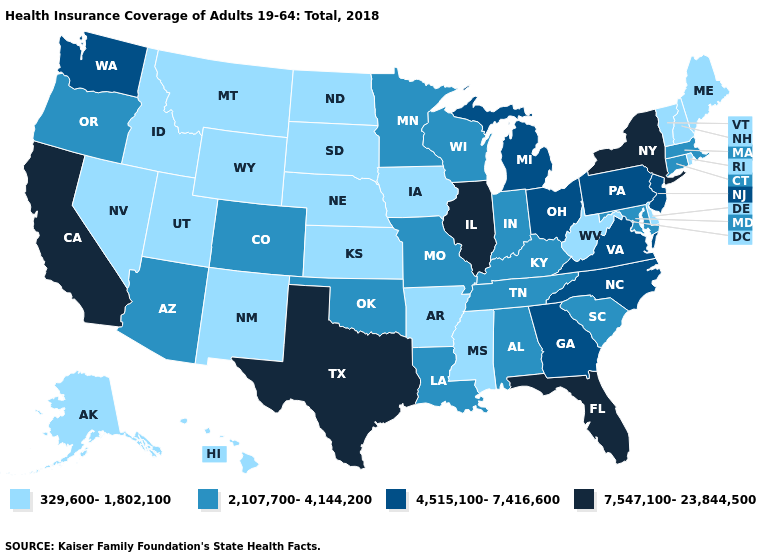Name the states that have a value in the range 329,600-1,802,100?
Write a very short answer. Alaska, Arkansas, Delaware, Hawaii, Idaho, Iowa, Kansas, Maine, Mississippi, Montana, Nebraska, Nevada, New Hampshire, New Mexico, North Dakota, Rhode Island, South Dakota, Utah, Vermont, West Virginia, Wyoming. Name the states that have a value in the range 2,107,700-4,144,200?
Keep it brief. Alabama, Arizona, Colorado, Connecticut, Indiana, Kentucky, Louisiana, Maryland, Massachusetts, Minnesota, Missouri, Oklahoma, Oregon, South Carolina, Tennessee, Wisconsin. What is the lowest value in the USA?
Be succinct. 329,600-1,802,100. Does the map have missing data?
Write a very short answer. No. Which states hav the highest value in the West?
Quick response, please. California. Which states have the highest value in the USA?
Concise answer only. California, Florida, Illinois, New York, Texas. Does Washington have the lowest value in the West?
Write a very short answer. No. Which states have the lowest value in the West?
Be succinct. Alaska, Hawaii, Idaho, Montana, Nevada, New Mexico, Utah, Wyoming. Name the states that have a value in the range 4,515,100-7,416,600?
Short answer required. Georgia, Michigan, New Jersey, North Carolina, Ohio, Pennsylvania, Virginia, Washington. Name the states that have a value in the range 4,515,100-7,416,600?
Keep it brief. Georgia, Michigan, New Jersey, North Carolina, Ohio, Pennsylvania, Virginia, Washington. What is the highest value in the USA?
Quick response, please. 7,547,100-23,844,500. Name the states that have a value in the range 329,600-1,802,100?
Concise answer only. Alaska, Arkansas, Delaware, Hawaii, Idaho, Iowa, Kansas, Maine, Mississippi, Montana, Nebraska, Nevada, New Hampshire, New Mexico, North Dakota, Rhode Island, South Dakota, Utah, Vermont, West Virginia, Wyoming. Which states hav the highest value in the West?
Concise answer only. California. Does Oklahoma have the highest value in the South?
Keep it brief. No. Name the states that have a value in the range 7,547,100-23,844,500?
Answer briefly. California, Florida, Illinois, New York, Texas. 